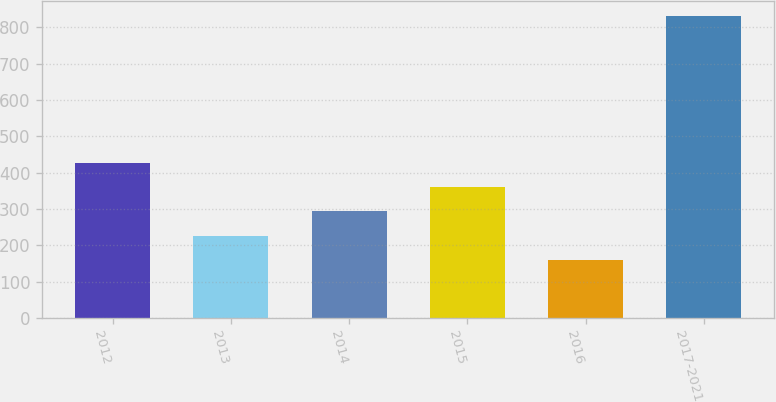<chart> <loc_0><loc_0><loc_500><loc_500><bar_chart><fcel>2012<fcel>2013<fcel>2014<fcel>2015<fcel>2016<fcel>2017-2021<nl><fcel>427.6<fcel>226.15<fcel>293.3<fcel>360.45<fcel>159<fcel>830.5<nl></chart> 